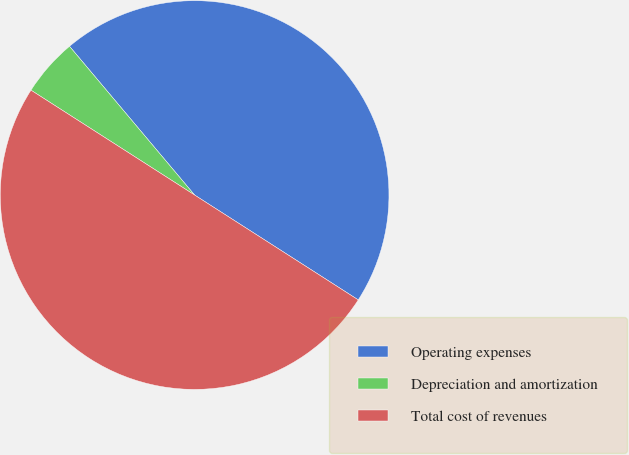Convert chart to OTSL. <chart><loc_0><loc_0><loc_500><loc_500><pie_chart><fcel>Operating expenses<fcel>Depreciation and amortization<fcel>Total cost of revenues<nl><fcel>45.2%<fcel>4.8%<fcel>50.0%<nl></chart> 